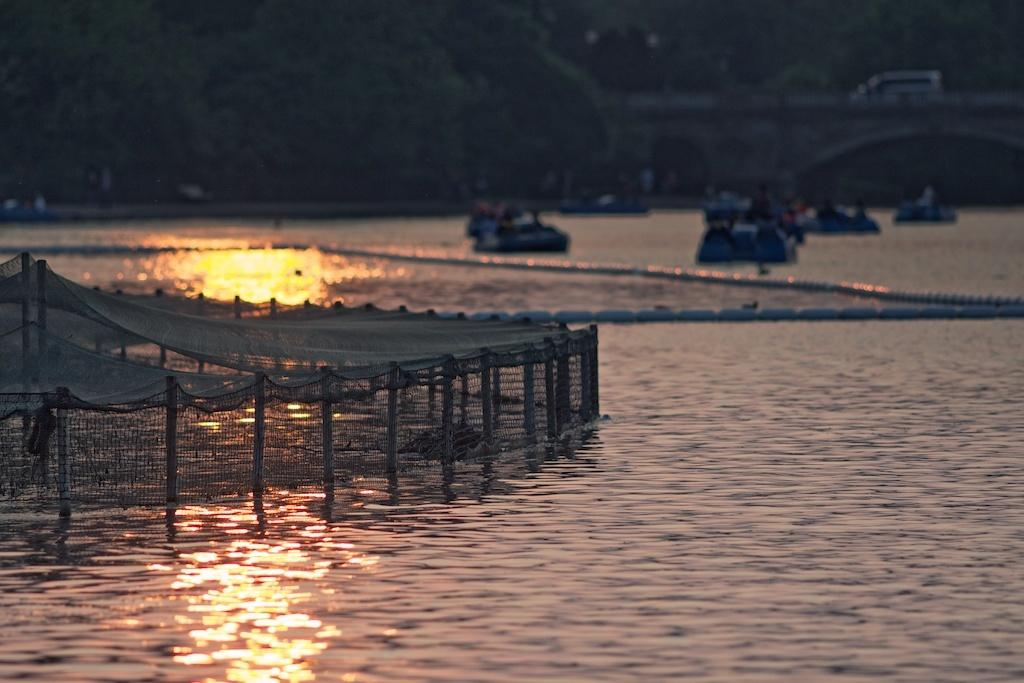What is located on the left side of the image? There is a net on the left side of the image. Where is the net situated? The net is on the water. What else can be seen on the water in the image? There are boats on the water. What structure is visible at the top side of the image? There is a car on a bridge at the top side of the image. What type of form can be seen coming out of the mouth of the woman in the image? There is no woman present in the image, so there is no mouth or form to be observed. 